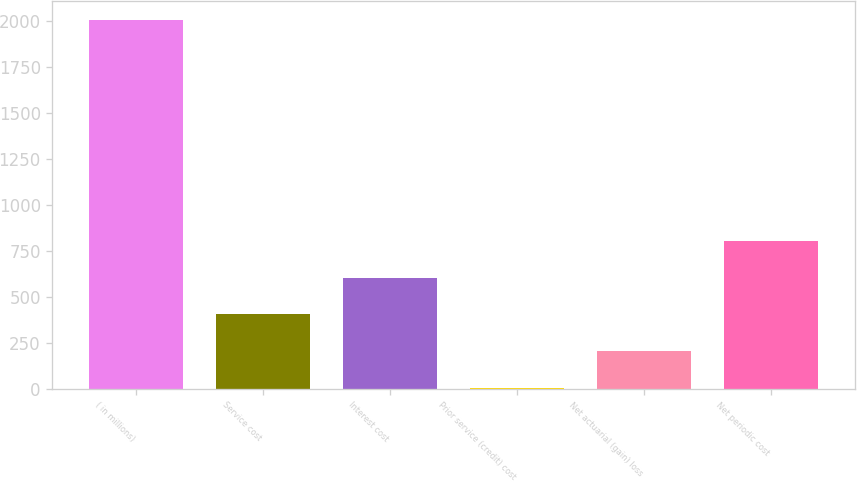Convert chart. <chart><loc_0><loc_0><loc_500><loc_500><bar_chart><fcel>( in millions)<fcel>Service cost<fcel>Interest cost<fcel>Prior service (credit) cost<fcel>Net actuarial (gain) loss<fcel>Net periodic cost<nl><fcel>2006<fcel>403.6<fcel>603.9<fcel>3<fcel>203.3<fcel>804.2<nl></chart> 